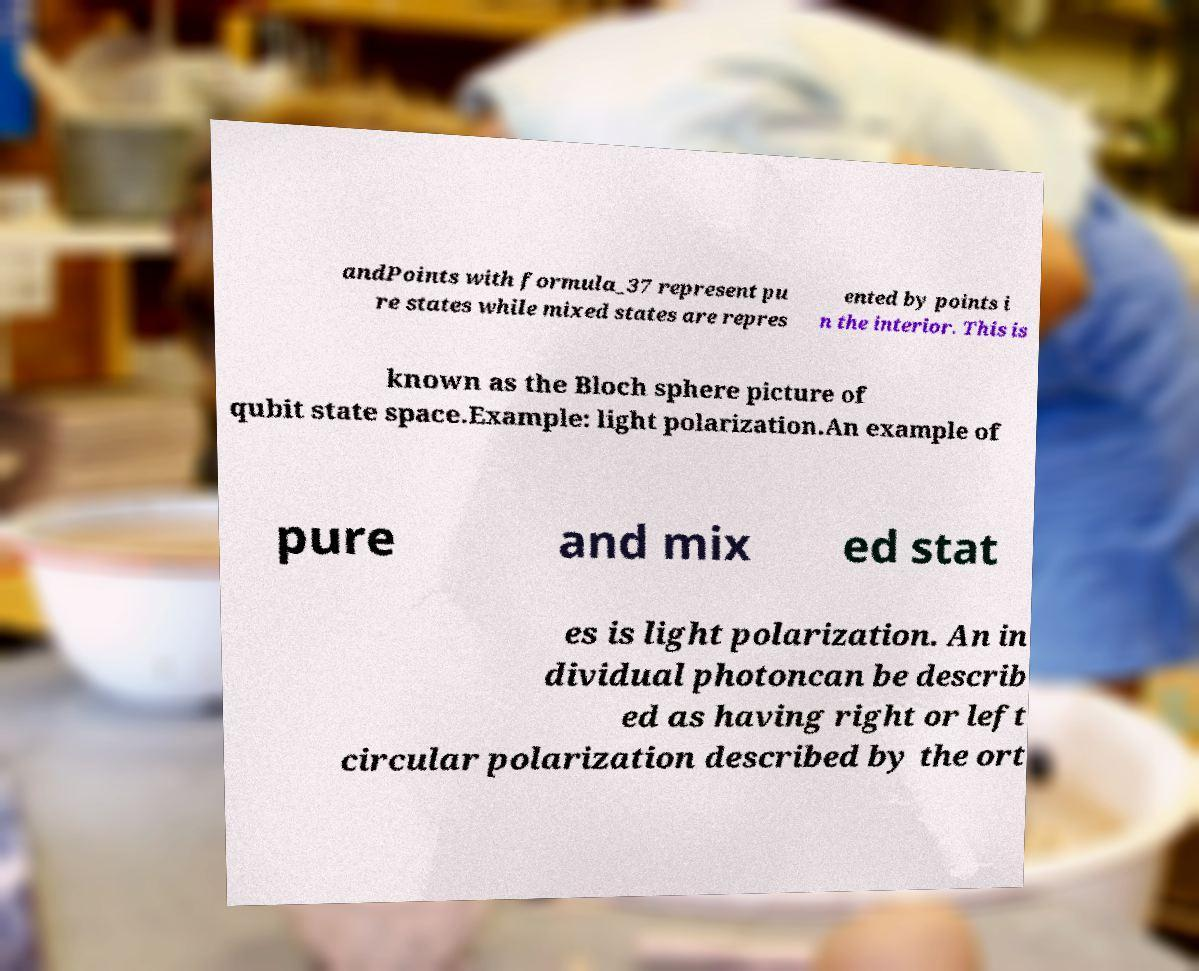Could you assist in decoding the text presented in this image and type it out clearly? andPoints with formula_37 represent pu re states while mixed states are repres ented by points i n the interior. This is known as the Bloch sphere picture of qubit state space.Example: light polarization.An example of pure and mix ed stat es is light polarization. An in dividual photoncan be describ ed as having right or left circular polarization described by the ort 